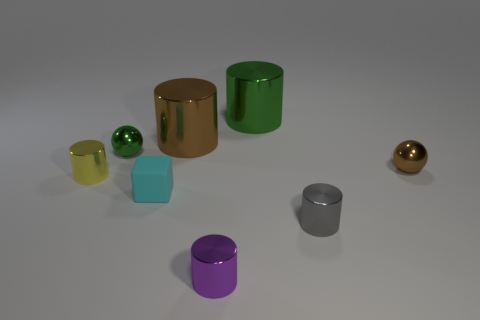What color is the other tiny ball that is the same material as the brown sphere?
Your response must be concise. Green. How many small yellow things are the same material as the small purple cylinder?
Provide a short and direct response. 1. There is a tiny yellow metal cylinder; what number of small gray cylinders are in front of it?
Provide a short and direct response. 1. Does the big thing that is on the left side of the purple shiny object have the same material as the small cylinder that is on the left side of the tiny purple metal object?
Make the answer very short. Yes. Are there more tiny rubber blocks left of the matte cube than small matte objects behind the tiny brown metal sphere?
Make the answer very short. No. Is there anything else that is the same shape as the purple object?
Your answer should be very brief. Yes. What is the object that is in front of the yellow cylinder and left of the purple thing made of?
Make the answer very short. Rubber. Are the small purple object and the small cylinder behind the small gray object made of the same material?
Your answer should be very brief. Yes. What number of things are small brown objects or tiny brown metallic balls that are in front of the large green metallic object?
Your answer should be very brief. 1. There is a brown shiny object that is on the left side of the small gray metallic object; is its size the same as the cyan thing behind the tiny gray object?
Ensure brevity in your answer.  No. 